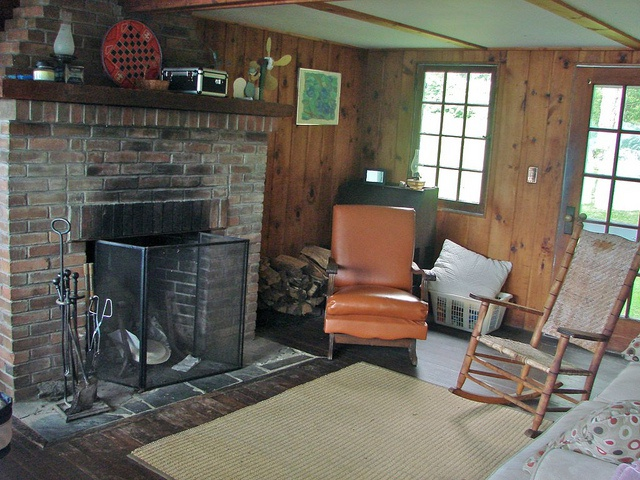Describe the objects in this image and their specific colors. I can see chair in black, darkgray, and gray tones, couch in black, brown, gray, and maroon tones, chair in black, brown, and maroon tones, couch in black, darkgray, and gray tones, and vase in black, gray, and darkgray tones in this image. 